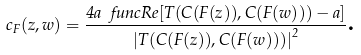Convert formula to latex. <formula><loc_0><loc_0><loc_500><loc_500>c _ { F } ( z , w ) = \frac { 4 a \ f u n c { R e } [ T ( C ( F ( z ) ) , C ( F ( w ) ) ) - a ] } { \left | T ( C ( F ( z ) ) , C ( F ( w ) ) ) \right | ^ { 2 } } \text {.}</formula> 